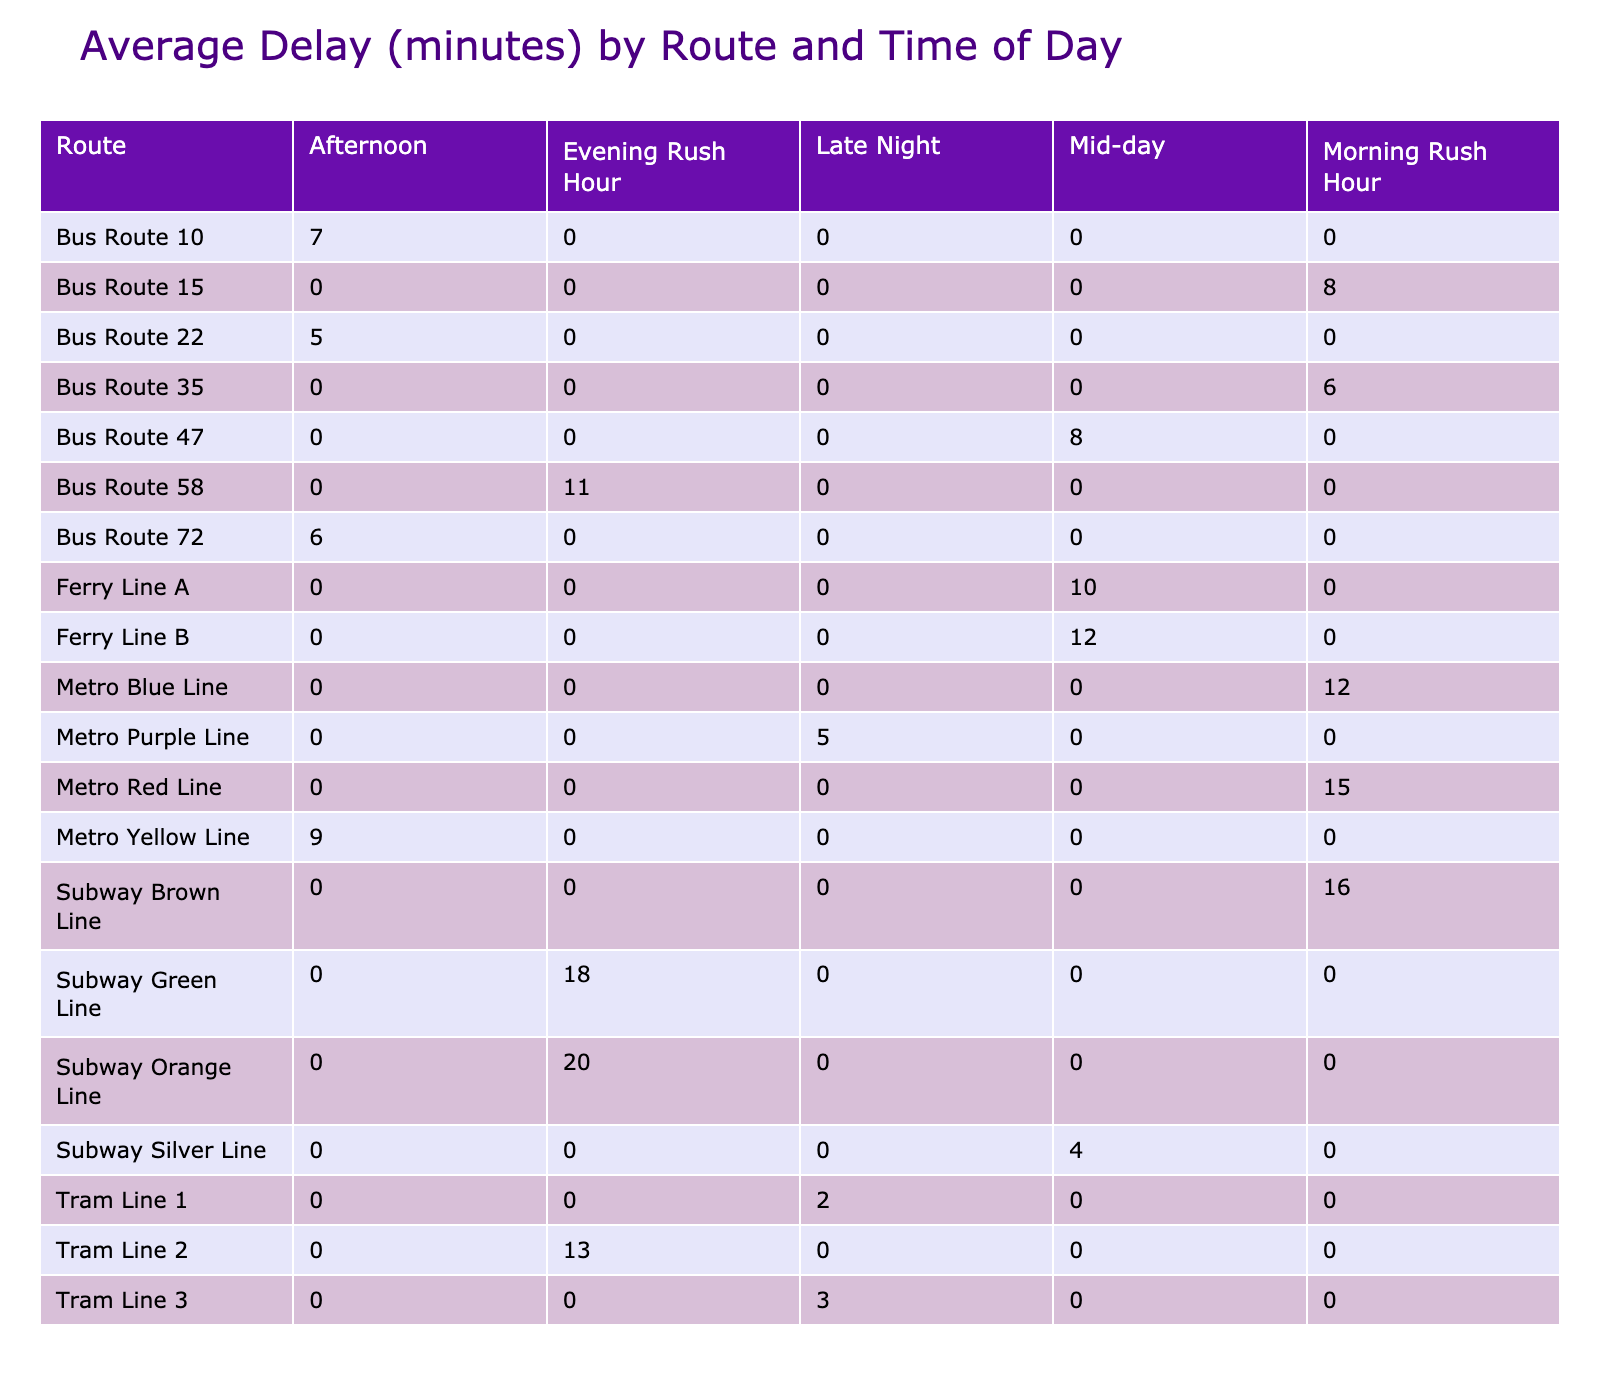What is the average delay for the Metro Blue Line during Morning Rush Hour? The delay for the Metro Blue Line during Morning Rush Hour is listed as 12 minutes in the table. Therefore, the average delay is 12 minutes.
Answer: 12 minutes Which route has the highest average delay during Evening Rush Hour? The routes listed for Evening Rush Hour are the Subway Green Line (18 minutes), Subway Orange Line (20 minutes), Bus Route 58 (11 minutes), and Tram Line 2 (13 minutes). Among these, the Subway Orange Line has the highest delay of 20 minutes.
Answer: Subway Orange Line What is the average delay of all routes during Afternoon time? The delays during Afternoon are: Bus Route 22 (5 minutes), Metro Yellow Line (9 minutes), Bus Route 72 (6 minutes), Subway Silver Line (4 minutes). The total delay is 5 + 9 + 6 + 4 = 24. There are 4 routes, so the average delay is 24/4 = 6 minutes.
Answer: 6 minutes Is there a route that has delays due to 'Vehicle Breakdown'? According to the table, the Bus Route 47 has a delay of 8 minutes due to 'Vehicle Breakdown'. Therefore, yes, there is a route with a delay for this reason.
Answer: Yes What is the difference in average delays between Morning Rush Hour and Late Night across all routes? The average delays during Morning Rush Hour are: Metro Blue Line (12 minutes), Metro Red Line (15 minutes), Bus Route 35 (6 minutes), Bus Route 15 (8 minutes), and Subway Brown Line (16 minutes). Their total is 12 + 15 + 6 + 8 + 16 = 57, leading to an average of 57/5 = 11.4 minutes. For Late Night, the delays are Tram Line 1 (2 minutes), Tram Line 3 (3 minutes), and Metro Purple Line (5 minutes). The total is 2 + 3 + 5 = 10, which gives an average of 10/3 ≈ 3.33 minutes. The difference is approximately 11.4 - 3.33 ≈ 8.07 minutes.
Answer: Approximately 8.07 minutes 